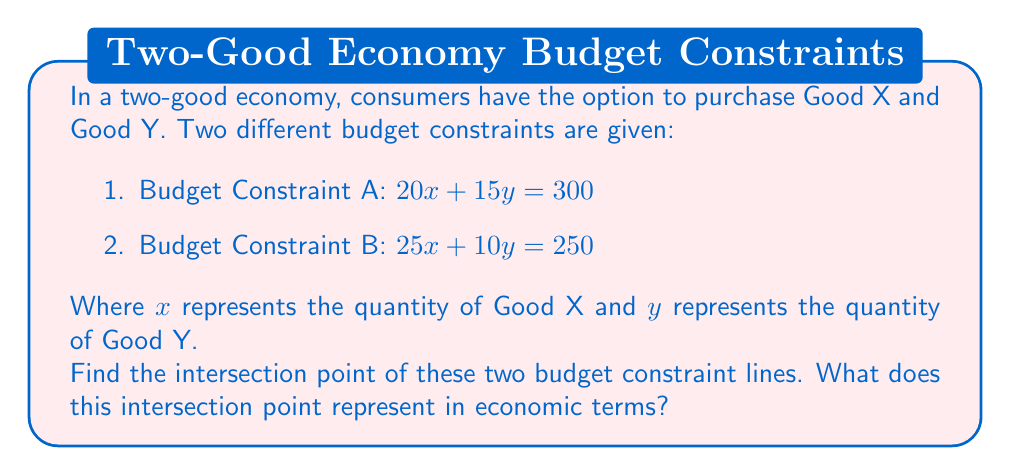Could you help me with this problem? To find the intersection point of the two budget constraint lines, we need to solve the system of equations:

$$
\begin{cases}
20x + 15y = 300 \\
25x + 10y = 250
\end{cases}
$$

Let's solve this using the substitution method:

1) From the first equation, express $y$ in terms of $x$:
   $20x + 15y = 300$
   $15y = 300 - 20x$
   $y = 20 - \frac{4}{3}x$

2) Substitute this expression for $y$ into the second equation:
   $25x + 10(20 - \frac{4}{3}x) = 250$

3) Simplify:
   $25x + 200 - \frac{40}{3}x = 250$
   $25x - \frac{40}{3}x = 50$
   $\frac{75x - 40x}{3} = 50$
   $\frac{35x}{3} = 50$

4) Solve for $x$:
   $x = \frac{150}{35} = \frac{30}{7} \approx 4.29$

5) Substitute this $x$ value back into either of the original equations to find $y$. Let's use the first equation:
   $20(\frac{30}{7}) + 15y = 300$
   $\frac{600}{7} + 15y = 300$
   $15y = 300 - \frac{600}{7} = \frac{2100 - 600}{7} = \frac{1500}{7}$
   $y = \frac{100}{7} \approx 14.29$

Therefore, the intersection point is $(\frac{30}{7}, \frac{100}{7})$ or approximately $(4.29, 14.29)$.

In economic terms, this intersection point represents a combination of Good X and Good Y that satisfies both budget constraints simultaneously. It indicates a point where a consumer could potentially switch between the two budget scenarios without changing their consumption bundle. This could be relevant in situations where a consumer is considering different income sources or spending plans that result in different budget constraints.
Answer: The intersection point of the two budget constraint lines is $(\frac{30}{7}, \frac{100}{7})$ or approximately $(4.29, 14.29)$. 